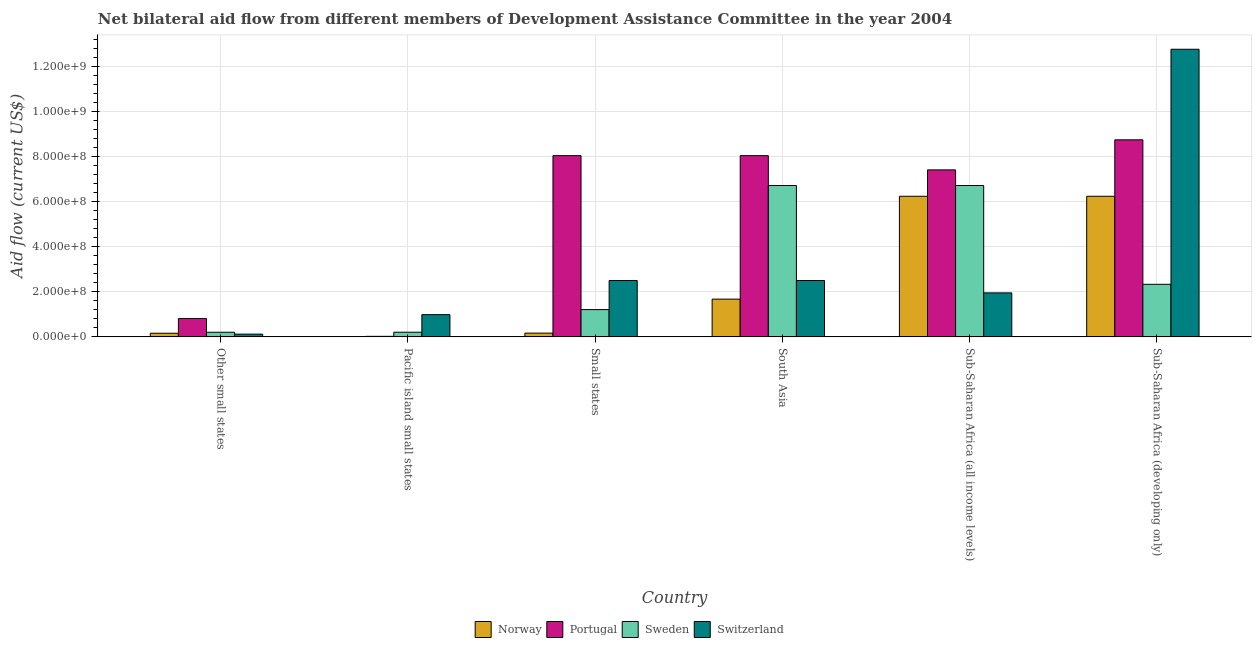Are the number of bars per tick equal to the number of legend labels?
Ensure brevity in your answer.  Yes. Are the number of bars on each tick of the X-axis equal?
Ensure brevity in your answer.  Yes. How many bars are there on the 6th tick from the left?
Provide a short and direct response. 4. How many bars are there on the 5th tick from the right?
Make the answer very short. 4. What is the label of the 5th group of bars from the left?
Your answer should be very brief. Sub-Saharan Africa (all income levels). What is the amount of aid given by portugal in Small states?
Make the answer very short. 8.04e+08. Across all countries, what is the maximum amount of aid given by portugal?
Make the answer very short. 8.74e+08. Across all countries, what is the minimum amount of aid given by switzerland?
Give a very brief answer. 1.22e+07. In which country was the amount of aid given by switzerland maximum?
Provide a short and direct response. Sub-Saharan Africa (developing only). In which country was the amount of aid given by norway minimum?
Provide a short and direct response. Pacific island small states. What is the total amount of aid given by switzerland in the graph?
Offer a very short reply. 2.08e+09. What is the difference between the amount of aid given by switzerland in Small states and that in Sub-Saharan Africa (developing only)?
Make the answer very short. -1.03e+09. What is the difference between the amount of aid given by portugal in Small states and the amount of aid given by switzerland in Other small states?
Give a very brief answer. 7.92e+08. What is the average amount of aid given by sweden per country?
Ensure brevity in your answer.  2.90e+08. What is the difference between the amount of aid given by switzerland and amount of aid given by sweden in Sub-Saharan Africa (all income levels)?
Make the answer very short. -4.76e+08. What is the ratio of the amount of aid given by norway in Pacific island small states to that in Sub-Saharan Africa (all income levels)?
Provide a succinct answer. 4.8117020594084814e-5. What is the difference between the highest and the second highest amount of aid given by switzerland?
Offer a very short reply. 1.03e+09. What is the difference between the highest and the lowest amount of aid given by switzerland?
Ensure brevity in your answer.  1.26e+09. What does the 3rd bar from the left in Other small states represents?
Ensure brevity in your answer.  Sweden. Is it the case that in every country, the sum of the amount of aid given by norway and amount of aid given by portugal is greater than the amount of aid given by sweden?
Offer a very short reply. No. Are all the bars in the graph horizontal?
Your response must be concise. No. Are the values on the major ticks of Y-axis written in scientific E-notation?
Offer a very short reply. Yes. Does the graph contain any zero values?
Your answer should be very brief. No. Does the graph contain grids?
Your answer should be very brief. Yes. How many legend labels are there?
Provide a succinct answer. 4. How are the legend labels stacked?
Give a very brief answer. Horizontal. What is the title of the graph?
Offer a terse response. Net bilateral aid flow from different members of Development Assistance Committee in the year 2004. What is the label or title of the X-axis?
Your answer should be very brief. Country. What is the Aid flow (current US$) of Norway in Other small states?
Your answer should be compact. 1.62e+07. What is the Aid flow (current US$) in Portugal in Other small states?
Your answer should be very brief. 8.14e+07. What is the Aid flow (current US$) of Sweden in Other small states?
Give a very brief answer. 2.04e+07. What is the Aid flow (current US$) in Switzerland in Other small states?
Provide a short and direct response. 1.22e+07. What is the Aid flow (current US$) in Portugal in Pacific island small states?
Give a very brief answer. 2.38e+06. What is the Aid flow (current US$) of Sweden in Pacific island small states?
Provide a short and direct response. 2.07e+07. What is the Aid flow (current US$) in Switzerland in Pacific island small states?
Provide a short and direct response. 9.84e+07. What is the Aid flow (current US$) of Norway in Small states?
Give a very brief answer. 1.66e+07. What is the Aid flow (current US$) of Portugal in Small states?
Your response must be concise. 8.04e+08. What is the Aid flow (current US$) in Sweden in Small states?
Keep it short and to the point. 1.21e+08. What is the Aid flow (current US$) of Switzerland in Small states?
Give a very brief answer. 2.50e+08. What is the Aid flow (current US$) in Norway in South Asia?
Ensure brevity in your answer.  1.67e+08. What is the Aid flow (current US$) in Portugal in South Asia?
Make the answer very short. 8.04e+08. What is the Aid flow (current US$) of Sweden in South Asia?
Make the answer very short. 6.71e+08. What is the Aid flow (current US$) of Switzerland in South Asia?
Your answer should be very brief. 2.50e+08. What is the Aid flow (current US$) in Norway in Sub-Saharan Africa (all income levels)?
Your answer should be very brief. 6.23e+08. What is the Aid flow (current US$) in Portugal in Sub-Saharan Africa (all income levels)?
Provide a succinct answer. 7.41e+08. What is the Aid flow (current US$) of Sweden in Sub-Saharan Africa (all income levels)?
Your answer should be compact. 6.71e+08. What is the Aid flow (current US$) of Switzerland in Sub-Saharan Africa (all income levels)?
Provide a succinct answer. 1.95e+08. What is the Aid flow (current US$) of Norway in Sub-Saharan Africa (developing only)?
Provide a succinct answer. 6.23e+08. What is the Aid flow (current US$) of Portugal in Sub-Saharan Africa (developing only)?
Your response must be concise. 8.74e+08. What is the Aid flow (current US$) of Sweden in Sub-Saharan Africa (developing only)?
Make the answer very short. 2.33e+08. What is the Aid flow (current US$) of Switzerland in Sub-Saharan Africa (developing only)?
Offer a terse response. 1.28e+09. Across all countries, what is the maximum Aid flow (current US$) in Norway?
Ensure brevity in your answer.  6.23e+08. Across all countries, what is the maximum Aid flow (current US$) in Portugal?
Your answer should be compact. 8.74e+08. Across all countries, what is the maximum Aid flow (current US$) of Sweden?
Your answer should be very brief. 6.71e+08. Across all countries, what is the maximum Aid flow (current US$) of Switzerland?
Provide a short and direct response. 1.28e+09. Across all countries, what is the minimum Aid flow (current US$) of Norway?
Ensure brevity in your answer.  3.00e+04. Across all countries, what is the minimum Aid flow (current US$) of Portugal?
Give a very brief answer. 2.38e+06. Across all countries, what is the minimum Aid flow (current US$) in Sweden?
Offer a very short reply. 2.04e+07. Across all countries, what is the minimum Aid flow (current US$) in Switzerland?
Offer a very short reply. 1.22e+07. What is the total Aid flow (current US$) in Norway in the graph?
Your answer should be compact. 1.45e+09. What is the total Aid flow (current US$) in Portugal in the graph?
Give a very brief answer. 3.31e+09. What is the total Aid flow (current US$) in Sweden in the graph?
Keep it short and to the point. 1.74e+09. What is the total Aid flow (current US$) in Switzerland in the graph?
Your answer should be very brief. 2.08e+09. What is the difference between the Aid flow (current US$) of Norway in Other small states and that in Pacific island small states?
Offer a terse response. 1.62e+07. What is the difference between the Aid flow (current US$) in Portugal in Other small states and that in Pacific island small states?
Ensure brevity in your answer.  7.90e+07. What is the difference between the Aid flow (current US$) in Sweden in Other small states and that in Pacific island small states?
Offer a very short reply. -2.40e+05. What is the difference between the Aid flow (current US$) in Switzerland in Other small states and that in Pacific island small states?
Provide a succinct answer. -8.63e+07. What is the difference between the Aid flow (current US$) of Norway in Other small states and that in Small states?
Your answer should be compact. -4.60e+05. What is the difference between the Aid flow (current US$) of Portugal in Other small states and that in Small states?
Your response must be concise. -7.22e+08. What is the difference between the Aid flow (current US$) of Sweden in Other small states and that in Small states?
Provide a succinct answer. -1.01e+08. What is the difference between the Aid flow (current US$) of Switzerland in Other small states and that in Small states?
Ensure brevity in your answer.  -2.38e+08. What is the difference between the Aid flow (current US$) in Norway in Other small states and that in South Asia?
Keep it short and to the point. -1.51e+08. What is the difference between the Aid flow (current US$) of Portugal in Other small states and that in South Asia?
Keep it short and to the point. -7.22e+08. What is the difference between the Aid flow (current US$) in Sweden in Other small states and that in South Asia?
Your response must be concise. -6.51e+08. What is the difference between the Aid flow (current US$) of Switzerland in Other small states and that in South Asia?
Give a very brief answer. -2.38e+08. What is the difference between the Aid flow (current US$) of Norway in Other small states and that in Sub-Saharan Africa (all income levels)?
Give a very brief answer. -6.07e+08. What is the difference between the Aid flow (current US$) in Portugal in Other small states and that in Sub-Saharan Africa (all income levels)?
Offer a terse response. -6.59e+08. What is the difference between the Aid flow (current US$) in Sweden in Other small states and that in Sub-Saharan Africa (all income levels)?
Provide a succinct answer. -6.51e+08. What is the difference between the Aid flow (current US$) in Switzerland in Other small states and that in Sub-Saharan Africa (all income levels)?
Offer a terse response. -1.83e+08. What is the difference between the Aid flow (current US$) in Norway in Other small states and that in Sub-Saharan Africa (developing only)?
Offer a terse response. -6.07e+08. What is the difference between the Aid flow (current US$) of Portugal in Other small states and that in Sub-Saharan Africa (developing only)?
Make the answer very short. -7.92e+08. What is the difference between the Aid flow (current US$) of Sweden in Other small states and that in Sub-Saharan Africa (developing only)?
Your answer should be very brief. -2.13e+08. What is the difference between the Aid flow (current US$) of Switzerland in Other small states and that in Sub-Saharan Africa (developing only)?
Provide a succinct answer. -1.26e+09. What is the difference between the Aid flow (current US$) of Norway in Pacific island small states and that in Small states?
Keep it short and to the point. -1.66e+07. What is the difference between the Aid flow (current US$) in Portugal in Pacific island small states and that in Small states?
Provide a short and direct response. -8.01e+08. What is the difference between the Aid flow (current US$) in Sweden in Pacific island small states and that in Small states?
Make the answer very short. -1.00e+08. What is the difference between the Aid flow (current US$) of Switzerland in Pacific island small states and that in Small states?
Your answer should be compact. -1.52e+08. What is the difference between the Aid flow (current US$) in Norway in Pacific island small states and that in South Asia?
Offer a very short reply. -1.67e+08. What is the difference between the Aid flow (current US$) of Portugal in Pacific island small states and that in South Asia?
Keep it short and to the point. -8.01e+08. What is the difference between the Aid flow (current US$) in Sweden in Pacific island small states and that in South Asia?
Provide a succinct answer. -6.50e+08. What is the difference between the Aid flow (current US$) in Switzerland in Pacific island small states and that in South Asia?
Offer a very short reply. -1.52e+08. What is the difference between the Aid flow (current US$) in Norway in Pacific island small states and that in Sub-Saharan Africa (all income levels)?
Give a very brief answer. -6.23e+08. What is the difference between the Aid flow (current US$) in Portugal in Pacific island small states and that in Sub-Saharan Africa (all income levels)?
Make the answer very short. -7.38e+08. What is the difference between the Aid flow (current US$) in Sweden in Pacific island small states and that in Sub-Saharan Africa (all income levels)?
Provide a short and direct response. -6.50e+08. What is the difference between the Aid flow (current US$) of Switzerland in Pacific island small states and that in Sub-Saharan Africa (all income levels)?
Keep it short and to the point. -9.66e+07. What is the difference between the Aid flow (current US$) of Norway in Pacific island small states and that in Sub-Saharan Africa (developing only)?
Your answer should be compact. -6.23e+08. What is the difference between the Aid flow (current US$) of Portugal in Pacific island small states and that in Sub-Saharan Africa (developing only)?
Your response must be concise. -8.71e+08. What is the difference between the Aid flow (current US$) in Sweden in Pacific island small states and that in Sub-Saharan Africa (developing only)?
Your response must be concise. -2.12e+08. What is the difference between the Aid flow (current US$) of Switzerland in Pacific island small states and that in Sub-Saharan Africa (developing only)?
Give a very brief answer. -1.18e+09. What is the difference between the Aid flow (current US$) in Norway in Small states and that in South Asia?
Keep it short and to the point. -1.51e+08. What is the difference between the Aid flow (current US$) of Portugal in Small states and that in South Asia?
Your answer should be compact. 5.00e+04. What is the difference between the Aid flow (current US$) of Sweden in Small states and that in South Asia?
Offer a terse response. -5.50e+08. What is the difference between the Aid flow (current US$) in Norway in Small states and that in Sub-Saharan Africa (all income levels)?
Provide a succinct answer. -6.07e+08. What is the difference between the Aid flow (current US$) of Portugal in Small states and that in Sub-Saharan Africa (all income levels)?
Offer a very short reply. 6.32e+07. What is the difference between the Aid flow (current US$) in Sweden in Small states and that in Sub-Saharan Africa (all income levels)?
Your answer should be very brief. -5.50e+08. What is the difference between the Aid flow (current US$) in Switzerland in Small states and that in Sub-Saharan Africa (all income levels)?
Offer a terse response. 5.50e+07. What is the difference between the Aid flow (current US$) in Norway in Small states and that in Sub-Saharan Africa (developing only)?
Give a very brief answer. -6.07e+08. What is the difference between the Aid flow (current US$) of Portugal in Small states and that in Sub-Saharan Africa (developing only)?
Your response must be concise. -7.02e+07. What is the difference between the Aid flow (current US$) in Sweden in Small states and that in Sub-Saharan Africa (developing only)?
Ensure brevity in your answer.  -1.12e+08. What is the difference between the Aid flow (current US$) in Switzerland in Small states and that in Sub-Saharan Africa (developing only)?
Make the answer very short. -1.03e+09. What is the difference between the Aid flow (current US$) of Norway in South Asia and that in Sub-Saharan Africa (all income levels)?
Provide a short and direct response. -4.56e+08. What is the difference between the Aid flow (current US$) in Portugal in South Asia and that in Sub-Saharan Africa (all income levels)?
Your answer should be compact. 6.31e+07. What is the difference between the Aid flow (current US$) in Sweden in South Asia and that in Sub-Saharan Africa (all income levels)?
Offer a very short reply. 0. What is the difference between the Aid flow (current US$) of Switzerland in South Asia and that in Sub-Saharan Africa (all income levels)?
Ensure brevity in your answer.  5.49e+07. What is the difference between the Aid flow (current US$) in Norway in South Asia and that in Sub-Saharan Africa (developing only)?
Your response must be concise. -4.56e+08. What is the difference between the Aid flow (current US$) of Portugal in South Asia and that in Sub-Saharan Africa (developing only)?
Provide a short and direct response. -7.02e+07. What is the difference between the Aid flow (current US$) of Sweden in South Asia and that in Sub-Saharan Africa (developing only)?
Your answer should be very brief. 4.38e+08. What is the difference between the Aid flow (current US$) of Switzerland in South Asia and that in Sub-Saharan Africa (developing only)?
Offer a very short reply. -1.03e+09. What is the difference between the Aid flow (current US$) of Portugal in Sub-Saharan Africa (all income levels) and that in Sub-Saharan Africa (developing only)?
Make the answer very short. -1.33e+08. What is the difference between the Aid flow (current US$) in Sweden in Sub-Saharan Africa (all income levels) and that in Sub-Saharan Africa (developing only)?
Offer a very short reply. 4.38e+08. What is the difference between the Aid flow (current US$) of Switzerland in Sub-Saharan Africa (all income levels) and that in Sub-Saharan Africa (developing only)?
Your response must be concise. -1.08e+09. What is the difference between the Aid flow (current US$) in Norway in Other small states and the Aid flow (current US$) in Portugal in Pacific island small states?
Provide a short and direct response. 1.38e+07. What is the difference between the Aid flow (current US$) in Norway in Other small states and the Aid flow (current US$) in Sweden in Pacific island small states?
Offer a terse response. -4.50e+06. What is the difference between the Aid flow (current US$) in Norway in Other small states and the Aid flow (current US$) in Switzerland in Pacific island small states?
Ensure brevity in your answer.  -8.23e+07. What is the difference between the Aid flow (current US$) in Portugal in Other small states and the Aid flow (current US$) in Sweden in Pacific island small states?
Give a very brief answer. 6.07e+07. What is the difference between the Aid flow (current US$) in Portugal in Other small states and the Aid flow (current US$) in Switzerland in Pacific island small states?
Your answer should be compact. -1.71e+07. What is the difference between the Aid flow (current US$) in Sweden in Other small states and the Aid flow (current US$) in Switzerland in Pacific island small states?
Provide a short and direct response. -7.80e+07. What is the difference between the Aid flow (current US$) in Norway in Other small states and the Aid flow (current US$) in Portugal in Small states?
Your response must be concise. -7.87e+08. What is the difference between the Aid flow (current US$) in Norway in Other small states and the Aid flow (current US$) in Sweden in Small states?
Your answer should be very brief. -1.05e+08. What is the difference between the Aid flow (current US$) in Norway in Other small states and the Aid flow (current US$) in Switzerland in Small states?
Ensure brevity in your answer.  -2.34e+08. What is the difference between the Aid flow (current US$) of Portugal in Other small states and the Aid flow (current US$) of Sweden in Small states?
Your response must be concise. -3.96e+07. What is the difference between the Aid flow (current US$) in Portugal in Other small states and the Aid flow (current US$) in Switzerland in Small states?
Provide a short and direct response. -1.69e+08. What is the difference between the Aid flow (current US$) in Sweden in Other small states and the Aid flow (current US$) in Switzerland in Small states?
Make the answer very short. -2.30e+08. What is the difference between the Aid flow (current US$) in Norway in Other small states and the Aid flow (current US$) in Portugal in South Asia?
Your response must be concise. -7.87e+08. What is the difference between the Aid flow (current US$) in Norway in Other small states and the Aid flow (current US$) in Sweden in South Asia?
Your response must be concise. -6.55e+08. What is the difference between the Aid flow (current US$) in Norway in Other small states and the Aid flow (current US$) in Switzerland in South Asia?
Provide a short and direct response. -2.34e+08. What is the difference between the Aid flow (current US$) of Portugal in Other small states and the Aid flow (current US$) of Sweden in South Asia?
Your response must be concise. -5.90e+08. What is the difference between the Aid flow (current US$) in Portugal in Other small states and the Aid flow (current US$) in Switzerland in South Asia?
Provide a short and direct response. -1.69e+08. What is the difference between the Aid flow (current US$) of Sweden in Other small states and the Aid flow (current US$) of Switzerland in South Asia?
Provide a short and direct response. -2.30e+08. What is the difference between the Aid flow (current US$) of Norway in Other small states and the Aid flow (current US$) of Portugal in Sub-Saharan Africa (all income levels)?
Provide a short and direct response. -7.24e+08. What is the difference between the Aid flow (current US$) of Norway in Other small states and the Aid flow (current US$) of Sweden in Sub-Saharan Africa (all income levels)?
Make the answer very short. -6.55e+08. What is the difference between the Aid flow (current US$) of Norway in Other small states and the Aid flow (current US$) of Switzerland in Sub-Saharan Africa (all income levels)?
Your answer should be compact. -1.79e+08. What is the difference between the Aid flow (current US$) of Portugal in Other small states and the Aid flow (current US$) of Sweden in Sub-Saharan Africa (all income levels)?
Make the answer very short. -5.90e+08. What is the difference between the Aid flow (current US$) of Portugal in Other small states and the Aid flow (current US$) of Switzerland in Sub-Saharan Africa (all income levels)?
Your answer should be very brief. -1.14e+08. What is the difference between the Aid flow (current US$) of Sweden in Other small states and the Aid flow (current US$) of Switzerland in Sub-Saharan Africa (all income levels)?
Provide a short and direct response. -1.75e+08. What is the difference between the Aid flow (current US$) of Norway in Other small states and the Aid flow (current US$) of Portugal in Sub-Saharan Africa (developing only)?
Offer a very short reply. -8.58e+08. What is the difference between the Aid flow (current US$) of Norway in Other small states and the Aid flow (current US$) of Sweden in Sub-Saharan Africa (developing only)?
Keep it short and to the point. -2.17e+08. What is the difference between the Aid flow (current US$) of Norway in Other small states and the Aid flow (current US$) of Switzerland in Sub-Saharan Africa (developing only)?
Your response must be concise. -1.26e+09. What is the difference between the Aid flow (current US$) in Portugal in Other small states and the Aid flow (current US$) in Sweden in Sub-Saharan Africa (developing only)?
Offer a terse response. -1.52e+08. What is the difference between the Aid flow (current US$) in Portugal in Other small states and the Aid flow (current US$) in Switzerland in Sub-Saharan Africa (developing only)?
Offer a terse response. -1.19e+09. What is the difference between the Aid flow (current US$) of Sweden in Other small states and the Aid flow (current US$) of Switzerland in Sub-Saharan Africa (developing only)?
Your response must be concise. -1.25e+09. What is the difference between the Aid flow (current US$) in Norway in Pacific island small states and the Aid flow (current US$) in Portugal in Small states?
Keep it short and to the point. -8.04e+08. What is the difference between the Aid flow (current US$) in Norway in Pacific island small states and the Aid flow (current US$) in Sweden in Small states?
Offer a terse response. -1.21e+08. What is the difference between the Aid flow (current US$) in Norway in Pacific island small states and the Aid flow (current US$) in Switzerland in Small states?
Offer a terse response. -2.50e+08. What is the difference between the Aid flow (current US$) in Portugal in Pacific island small states and the Aid flow (current US$) in Sweden in Small states?
Keep it short and to the point. -1.19e+08. What is the difference between the Aid flow (current US$) in Portugal in Pacific island small states and the Aid flow (current US$) in Switzerland in Small states?
Make the answer very short. -2.48e+08. What is the difference between the Aid flow (current US$) in Sweden in Pacific island small states and the Aid flow (current US$) in Switzerland in Small states?
Your answer should be very brief. -2.29e+08. What is the difference between the Aid flow (current US$) of Norway in Pacific island small states and the Aid flow (current US$) of Portugal in South Asia?
Provide a succinct answer. -8.04e+08. What is the difference between the Aid flow (current US$) in Norway in Pacific island small states and the Aid flow (current US$) in Sweden in South Asia?
Your response must be concise. -6.71e+08. What is the difference between the Aid flow (current US$) of Norway in Pacific island small states and the Aid flow (current US$) of Switzerland in South Asia?
Give a very brief answer. -2.50e+08. What is the difference between the Aid flow (current US$) in Portugal in Pacific island small states and the Aid flow (current US$) in Sweden in South Asia?
Ensure brevity in your answer.  -6.69e+08. What is the difference between the Aid flow (current US$) of Portugal in Pacific island small states and the Aid flow (current US$) of Switzerland in South Asia?
Give a very brief answer. -2.48e+08. What is the difference between the Aid flow (current US$) in Sweden in Pacific island small states and the Aid flow (current US$) in Switzerland in South Asia?
Make the answer very short. -2.29e+08. What is the difference between the Aid flow (current US$) in Norway in Pacific island small states and the Aid flow (current US$) in Portugal in Sub-Saharan Africa (all income levels)?
Give a very brief answer. -7.40e+08. What is the difference between the Aid flow (current US$) of Norway in Pacific island small states and the Aid flow (current US$) of Sweden in Sub-Saharan Africa (all income levels)?
Offer a terse response. -6.71e+08. What is the difference between the Aid flow (current US$) in Norway in Pacific island small states and the Aid flow (current US$) in Switzerland in Sub-Saharan Africa (all income levels)?
Give a very brief answer. -1.95e+08. What is the difference between the Aid flow (current US$) of Portugal in Pacific island small states and the Aid flow (current US$) of Sweden in Sub-Saharan Africa (all income levels)?
Offer a very short reply. -6.69e+08. What is the difference between the Aid flow (current US$) in Portugal in Pacific island small states and the Aid flow (current US$) in Switzerland in Sub-Saharan Africa (all income levels)?
Provide a short and direct response. -1.93e+08. What is the difference between the Aid flow (current US$) in Sweden in Pacific island small states and the Aid flow (current US$) in Switzerland in Sub-Saharan Africa (all income levels)?
Your answer should be compact. -1.74e+08. What is the difference between the Aid flow (current US$) of Norway in Pacific island small states and the Aid flow (current US$) of Portugal in Sub-Saharan Africa (developing only)?
Keep it short and to the point. -8.74e+08. What is the difference between the Aid flow (current US$) in Norway in Pacific island small states and the Aid flow (current US$) in Sweden in Sub-Saharan Africa (developing only)?
Offer a terse response. -2.33e+08. What is the difference between the Aid flow (current US$) in Norway in Pacific island small states and the Aid flow (current US$) in Switzerland in Sub-Saharan Africa (developing only)?
Your answer should be compact. -1.28e+09. What is the difference between the Aid flow (current US$) of Portugal in Pacific island small states and the Aid flow (current US$) of Sweden in Sub-Saharan Africa (developing only)?
Your answer should be compact. -2.31e+08. What is the difference between the Aid flow (current US$) of Portugal in Pacific island small states and the Aid flow (current US$) of Switzerland in Sub-Saharan Africa (developing only)?
Your answer should be very brief. -1.27e+09. What is the difference between the Aid flow (current US$) in Sweden in Pacific island small states and the Aid flow (current US$) in Switzerland in Sub-Saharan Africa (developing only)?
Provide a succinct answer. -1.25e+09. What is the difference between the Aid flow (current US$) in Norway in Small states and the Aid flow (current US$) in Portugal in South Asia?
Offer a very short reply. -7.87e+08. What is the difference between the Aid flow (current US$) of Norway in Small states and the Aid flow (current US$) of Sweden in South Asia?
Ensure brevity in your answer.  -6.54e+08. What is the difference between the Aid flow (current US$) in Norway in Small states and the Aid flow (current US$) in Switzerland in South Asia?
Provide a succinct answer. -2.33e+08. What is the difference between the Aid flow (current US$) in Portugal in Small states and the Aid flow (current US$) in Sweden in South Asia?
Offer a terse response. 1.33e+08. What is the difference between the Aid flow (current US$) of Portugal in Small states and the Aid flow (current US$) of Switzerland in South Asia?
Give a very brief answer. 5.54e+08. What is the difference between the Aid flow (current US$) in Sweden in Small states and the Aid flow (current US$) in Switzerland in South Asia?
Provide a succinct answer. -1.29e+08. What is the difference between the Aid flow (current US$) of Norway in Small states and the Aid flow (current US$) of Portugal in Sub-Saharan Africa (all income levels)?
Your answer should be compact. -7.24e+08. What is the difference between the Aid flow (current US$) in Norway in Small states and the Aid flow (current US$) in Sweden in Sub-Saharan Africa (all income levels)?
Provide a succinct answer. -6.54e+08. What is the difference between the Aid flow (current US$) of Norway in Small states and the Aid flow (current US$) of Switzerland in Sub-Saharan Africa (all income levels)?
Provide a short and direct response. -1.78e+08. What is the difference between the Aid flow (current US$) in Portugal in Small states and the Aid flow (current US$) in Sweden in Sub-Saharan Africa (all income levels)?
Offer a terse response. 1.33e+08. What is the difference between the Aid flow (current US$) in Portugal in Small states and the Aid flow (current US$) in Switzerland in Sub-Saharan Africa (all income levels)?
Give a very brief answer. 6.09e+08. What is the difference between the Aid flow (current US$) of Sweden in Small states and the Aid flow (current US$) of Switzerland in Sub-Saharan Africa (all income levels)?
Your answer should be compact. -7.41e+07. What is the difference between the Aid flow (current US$) in Norway in Small states and the Aid flow (current US$) in Portugal in Sub-Saharan Africa (developing only)?
Keep it short and to the point. -8.57e+08. What is the difference between the Aid flow (current US$) of Norway in Small states and the Aid flow (current US$) of Sweden in Sub-Saharan Africa (developing only)?
Give a very brief answer. -2.16e+08. What is the difference between the Aid flow (current US$) in Norway in Small states and the Aid flow (current US$) in Switzerland in Sub-Saharan Africa (developing only)?
Keep it short and to the point. -1.26e+09. What is the difference between the Aid flow (current US$) in Portugal in Small states and the Aid flow (current US$) in Sweden in Sub-Saharan Africa (developing only)?
Your answer should be compact. 5.71e+08. What is the difference between the Aid flow (current US$) of Portugal in Small states and the Aid flow (current US$) of Switzerland in Sub-Saharan Africa (developing only)?
Make the answer very short. -4.72e+08. What is the difference between the Aid flow (current US$) in Sweden in Small states and the Aid flow (current US$) in Switzerland in Sub-Saharan Africa (developing only)?
Provide a succinct answer. -1.15e+09. What is the difference between the Aid flow (current US$) of Norway in South Asia and the Aid flow (current US$) of Portugal in Sub-Saharan Africa (all income levels)?
Give a very brief answer. -5.73e+08. What is the difference between the Aid flow (current US$) of Norway in South Asia and the Aid flow (current US$) of Sweden in Sub-Saharan Africa (all income levels)?
Offer a terse response. -5.04e+08. What is the difference between the Aid flow (current US$) in Norway in South Asia and the Aid flow (current US$) in Switzerland in Sub-Saharan Africa (all income levels)?
Provide a succinct answer. -2.77e+07. What is the difference between the Aid flow (current US$) of Portugal in South Asia and the Aid flow (current US$) of Sweden in Sub-Saharan Africa (all income levels)?
Provide a succinct answer. 1.32e+08. What is the difference between the Aid flow (current US$) of Portugal in South Asia and the Aid flow (current US$) of Switzerland in Sub-Saharan Africa (all income levels)?
Offer a terse response. 6.09e+08. What is the difference between the Aid flow (current US$) of Sweden in South Asia and the Aid flow (current US$) of Switzerland in Sub-Saharan Africa (all income levels)?
Keep it short and to the point. 4.76e+08. What is the difference between the Aid flow (current US$) of Norway in South Asia and the Aid flow (current US$) of Portugal in Sub-Saharan Africa (developing only)?
Keep it short and to the point. -7.06e+08. What is the difference between the Aid flow (current US$) of Norway in South Asia and the Aid flow (current US$) of Sweden in Sub-Saharan Africa (developing only)?
Ensure brevity in your answer.  -6.57e+07. What is the difference between the Aid flow (current US$) of Norway in South Asia and the Aid flow (current US$) of Switzerland in Sub-Saharan Africa (developing only)?
Provide a succinct answer. -1.11e+09. What is the difference between the Aid flow (current US$) of Portugal in South Asia and the Aid flow (current US$) of Sweden in Sub-Saharan Africa (developing only)?
Make the answer very short. 5.71e+08. What is the difference between the Aid flow (current US$) in Portugal in South Asia and the Aid flow (current US$) in Switzerland in Sub-Saharan Africa (developing only)?
Make the answer very short. -4.72e+08. What is the difference between the Aid flow (current US$) in Sweden in South Asia and the Aid flow (current US$) in Switzerland in Sub-Saharan Africa (developing only)?
Offer a very short reply. -6.04e+08. What is the difference between the Aid flow (current US$) of Norway in Sub-Saharan Africa (all income levels) and the Aid flow (current US$) of Portugal in Sub-Saharan Africa (developing only)?
Ensure brevity in your answer.  -2.50e+08. What is the difference between the Aid flow (current US$) of Norway in Sub-Saharan Africa (all income levels) and the Aid flow (current US$) of Sweden in Sub-Saharan Africa (developing only)?
Your answer should be very brief. 3.90e+08. What is the difference between the Aid flow (current US$) in Norway in Sub-Saharan Africa (all income levels) and the Aid flow (current US$) in Switzerland in Sub-Saharan Africa (developing only)?
Offer a terse response. -6.52e+08. What is the difference between the Aid flow (current US$) in Portugal in Sub-Saharan Africa (all income levels) and the Aid flow (current US$) in Sweden in Sub-Saharan Africa (developing only)?
Ensure brevity in your answer.  5.07e+08. What is the difference between the Aid flow (current US$) in Portugal in Sub-Saharan Africa (all income levels) and the Aid flow (current US$) in Switzerland in Sub-Saharan Africa (developing only)?
Your response must be concise. -5.35e+08. What is the difference between the Aid flow (current US$) in Sweden in Sub-Saharan Africa (all income levels) and the Aid flow (current US$) in Switzerland in Sub-Saharan Africa (developing only)?
Give a very brief answer. -6.04e+08. What is the average Aid flow (current US$) in Norway per country?
Provide a succinct answer. 2.41e+08. What is the average Aid flow (current US$) in Portugal per country?
Provide a short and direct response. 5.51e+08. What is the average Aid flow (current US$) in Sweden per country?
Give a very brief answer. 2.90e+08. What is the average Aid flow (current US$) of Switzerland per country?
Give a very brief answer. 3.47e+08. What is the difference between the Aid flow (current US$) in Norway and Aid flow (current US$) in Portugal in Other small states?
Keep it short and to the point. -6.52e+07. What is the difference between the Aid flow (current US$) in Norway and Aid flow (current US$) in Sweden in Other small states?
Ensure brevity in your answer.  -4.26e+06. What is the difference between the Aid flow (current US$) of Norway and Aid flow (current US$) of Switzerland in Other small states?
Ensure brevity in your answer.  4.02e+06. What is the difference between the Aid flow (current US$) of Portugal and Aid flow (current US$) of Sweden in Other small states?
Ensure brevity in your answer.  6.09e+07. What is the difference between the Aid flow (current US$) in Portugal and Aid flow (current US$) in Switzerland in Other small states?
Offer a terse response. 6.92e+07. What is the difference between the Aid flow (current US$) of Sweden and Aid flow (current US$) of Switzerland in Other small states?
Your response must be concise. 8.28e+06. What is the difference between the Aid flow (current US$) in Norway and Aid flow (current US$) in Portugal in Pacific island small states?
Offer a very short reply. -2.35e+06. What is the difference between the Aid flow (current US$) of Norway and Aid flow (current US$) of Sweden in Pacific island small states?
Your answer should be compact. -2.07e+07. What is the difference between the Aid flow (current US$) of Norway and Aid flow (current US$) of Switzerland in Pacific island small states?
Keep it short and to the point. -9.84e+07. What is the difference between the Aid flow (current US$) of Portugal and Aid flow (current US$) of Sweden in Pacific island small states?
Your response must be concise. -1.83e+07. What is the difference between the Aid flow (current US$) of Portugal and Aid flow (current US$) of Switzerland in Pacific island small states?
Offer a very short reply. -9.61e+07. What is the difference between the Aid flow (current US$) of Sweden and Aid flow (current US$) of Switzerland in Pacific island small states?
Make the answer very short. -7.78e+07. What is the difference between the Aid flow (current US$) in Norway and Aid flow (current US$) in Portugal in Small states?
Offer a very short reply. -7.87e+08. What is the difference between the Aid flow (current US$) in Norway and Aid flow (current US$) in Sweden in Small states?
Offer a terse response. -1.04e+08. What is the difference between the Aid flow (current US$) of Norway and Aid flow (current US$) of Switzerland in Small states?
Your response must be concise. -2.33e+08. What is the difference between the Aid flow (current US$) in Portugal and Aid flow (current US$) in Sweden in Small states?
Your answer should be very brief. 6.83e+08. What is the difference between the Aid flow (current US$) of Portugal and Aid flow (current US$) of Switzerland in Small states?
Ensure brevity in your answer.  5.54e+08. What is the difference between the Aid flow (current US$) of Sweden and Aid flow (current US$) of Switzerland in Small states?
Your response must be concise. -1.29e+08. What is the difference between the Aid flow (current US$) in Norway and Aid flow (current US$) in Portugal in South Asia?
Provide a succinct answer. -6.36e+08. What is the difference between the Aid flow (current US$) in Norway and Aid flow (current US$) in Sweden in South Asia?
Make the answer very short. -5.04e+08. What is the difference between the Aid flow (current US$) of Norway and Aid flow (current US$) of Switzerland in South Asia?
Offer a very short reply. -8.26e+07. What is the difference between the Aid flow (current US$) of Portugal and Aid flow (current US$) of Sweden in South Asia?
Keep it short and to the point. 1.32e+08. What is the difference between the Aid flow (current US$) of Portugal and Aid flow (current US$) of Switzerland in South Asia?
Keep it short and to the point. 5.54e+08. What is the difference between the Aid flow (current US$) in Sweden and Aid flow (current US$) in Switzerland in South Asia?
Your answer should be very brief. 4.21e+08. What is the difference between the Aid flow (current US$) in Norway and Aid flow (current US$) in Portugal in Sub-Saharan Africa (all income levels)?
Provide a succinct answer. -1.17e+08. What is the difference between the Aid flow (current US$) of Norway and Aid flow (current US$) of Sweden in Sub-Saharan Africa (all income levels)?
Your answer should be compact. -4.77e+07. What is the difference between the Aid flow (current US$) in Norway and Aid flow (current US$) in Switzerland in Sub-Saharan Africa (all income levels)?
Keep it short and to the point. 4.28e+08. What is the difference between the Aid flow (current US$) in Portugal and Aid flow (current US$) in Sweden in Sub-Saharan Africa (all income levels)?
Make the answer very short. 6.94e+07. What is the difference between the Aid flow (current US$) of Portugal and Aid flow (current US$) of Switzerland in Sub-Saharan Africa (all income levels)?
Ensure brevity in your answer.  5.45e+08. What is the difference between the Aid flow (current US$) in Sweden and Aid flow (current US$) in Switzerland in Sub-Saharan Africa (all income levels)?
Keep it short and to the point. 4.76e+08. What is the difference between the Aid flow (current US$) of Norway and Aid flow (current US$) of Portugal in Sub-Saharan Africa (developing only)?
Ensure brevity in your answer.  -2.50e+08. What is the difference between the Aid flow (current US$) of Norway and Aid flow (current US$) of Sweden in Sub-Saharan Africa (developing only)?
Offer a terse response. 3.90e+08. What is the difference between the Aid flow (current US$) in Norway and Aid flow (current US$) in Switzerland in Sub-Saharan Africa (developing only)?
Keep it short and to the point. -6.52e+08. What is the difference between the Aid flow (current US$) of Portugal and Aid flow (current US$) of Sweden in Sub-Saharan Africa (developing only)?
Ensure brevity in your answer.  6.41e+08. What is the difference between the Aid flow (current US$) in Portugal and Aid flow (current US$) in Switzerland in Sub-Saharan Africa (developing only)?
Provide a succinct answer. -4.02e+08. What is the difference between the Aid flow (current US$) in Sweden and Aid flow (current US$) in Switzerland in Sub-Saharan Africa (developing only)?
Offer a terse response. -1.04e+09. What is the ratio of the Aid flow (current US$) of Norway in Other small states to that in Pacific island small states?
Provide a succinct answer. 539.67. What is the ratio of the Aid flow (current US$) of Portugal in Other small states to that in Pacific island small states?
Offer a very short reply. 34.19. What is the ratio of the Aid flow (current US$) of Sweden in Other small states to that in Pacific island small states?
Provide a short and direct response. 0.99. What is the ratio of the Aid flow (current US$) in Switzerland in Other small states to that in Pacific island small states?
Ensure brevity in your answer.  0.12. What is the ratio of the Aid flow (current US$) of Norway in Other small states to that in Small states?
Your answer should be compact. 0.97. What is the ratio of the Aid flow (current US$) in Portugal in Other small states to that in Small states?
Your answer should be compact. 0.1. What is the ratio of the Aid flow (current US$) of Sweden in Other small states to that in Small states?
Your answer should be compact. 0.17. What is the ratio of the Aid flow (current US$) of Switzerland in Other small states to that in Small states?
Make the answer very short. 0.05. What is the ratio of the Aid flow (current US$) of Norway in Other small states to that in South Asia?
Give a very brief answer. 0.1. What is the ratio of the Aid flow (current US$) of Portugal in Other small states to that in South Asia?
Provide a short and direct response. 0.1. What is the ratio of the Aid flow (current US$) in Sweden in Other small states to that in South Asia?
Your response must be concise. 0.03. What is the ratio of the Aid flow (current US$) in Switzerland in Other small states to that in South Asia?
Your response must be concise. 0.05. What is the ratio of the Aid flow (current US$) of Norway in Other small states to that in Sub-Saharan Africa (all income levels)?
Ensure brevity in your answer.  0.03. What is the ratio of the Aid flow (current US$) in Portugal in Other small states to that in Sub-Saharan Africa (all income levels)?
Give a very brief answer. 0.11. What is the ratio of the Aid flow (current US$) in Sweden in Other small states to that in Sub-Saharan Africa (all income levels)?
Your response must be concise. 0.03. What is the ratio of the Aid flow (current US$) in Switzerland in Other small states to that in Sub-Saharan Africa (all income levels)?
Give a very brief answer. 0.06. What is the ratio of the Aid flow (current US$) of Norway in Other small states to that in Sub-Saharan Africa (developing only)?
Offer a very short reply. 0.03. What is the ratio of the Aid flow (current US$) in Portugal in Other small states to that in Sub-Saharan Africa (developing only)?
Provide a short and direct response. 0.09. What is the ratio of the Aid flow (current US$) in Sweden in Other small states to that in Sub-Saharan Africa (developing only)?
Provide a short and direct response. 0.09. What is the ratio of the Aid flow (current US$) in Switzerland in Other small states to that in Sub-Saharan Africa (developing only)?
Your answer should be very brief. 0.01. What is the ratio of the Aid flow (current US$) in Norway in Pacific island small states to that in Small states?
Give a very brief answer. 0. What is the ratio of the Aid flow (current US$) in Portugal in Pacific island small states to that in Small states?
Offer a terse response. 0. What is the ratio of the Aid flow (current US$) of Sweden in Pacific island small states to that in Small states?
Provide a short and direct response. 0.17. What is the ratio of the Aid flow (current US$) in Switzerland in Pacific island small states to that in Small states?
Give a very brief answer. 0.39. What is the ratio of the Aid flow (current US$) of Portugal in Pacific island small states to that in South Asia?
Keep it short and to the point. 0. What is the ratio of the Aid flow (current US$) in Sweden in Pacific island small states to that in South Asia?
Provide a succinct answer. 0.03. What is the ratio of the Aid flow (current US$) in Switzerland in Pacific island small states to that in South Asia?
Your answer should be very brief. 0.39. What is the ratio of the Aid flow (current US$) of Norway in Pacific island small states to that in Sub-Saharan Africa (all income levels)?
Ensure brevity in your answer.  0. What is the ratio of the Aid flow (current US$) in Portugal in Pacific island small states to that in Sub-Saharan Africa (all income levels)?
Provide a succinct answer. 0. What is the ratio of the Aid flow (current US$) in Sweden in Pacific island small states to that in Sub-Saharan Africa (all income levels)?
Provide a short and direct response. 0.03. What is the ratio of the Aid flow (current US$) of Switzerland in Pacific island small states to that in Sub-Saharan Africa (all income levels)?
Offer a terse response. 0.5. What is the ratio of the Aid flow (current US$) in Portugal in Pacific island small states to that in Sub-Saharan Africa (developing only)?
Keep it short and to the point. 0. What is the ratio of the Aid flow (current US$) of Sweden in Pacific island small states to that in Sub-Saharan Africa (developing only)?
Your response must be concise. 0.09. What is the ratio of the Aid flow (current US$) in Switzerland in Pacific island small states to that in Sub-Saharan Africa (developing only)?
Make the answer very short. 0.08. What is the ratio of the Aid flow (current US$) of Norway in Small states to that in South Asia?
Make the answer very short. 0.1. What is the ratio of the Aid flow (current US$) of Sweden in Small states to that in South Asia?
Provide a short and direct response. 0.18. What is the ratio of the Aid flow (current US$) of Norway in Small states to that in Sub-Saharan Africa (all income levels)?
Ensure brevity in your answer.  0.03. What is the ratio of the Aid flow (current US$) in Portugal in Small states to that in Sub-Saharan Africa (all income levels)?
Your answer should be compact. 1.09. What is the ratio of the Aid flow (current US$) in Sweden in Small states to that in Sub-Saharan Africa (all income levels)?
Provide a short and direct response. 0.18. What is the ratio of the Aid flow (current US$) in Switzerland in Small states to that in Sub-Saharan Africa (all income levels)?
Give a very brief answer. 1.28. What is the ratio of the Aid flow (current US$) of Norway in Small states to that in Sub-Saharan Africa (developing only)?
Offer a very short reply. 0.03. What is the ratio of the Aid flow (current US$) of Portugal in Small states to that in Sub-Saharan Africa (developing only)?
Provide a succinct answer. 0.92. What is the ratio of the Aid flow (current US$) of Sweden in Small states to that in Sub-Saharan Africa (developing only)?
Provide a succinct answer. 0.52. What is the ratio of the Aid flow (current US$) in Switzerland in Small states to that in Sub-Saharan Africa (developing only)?
Provide a succinct answer. 0.2. What is the ratio of the Aid flow (current US$) in Norway in South Asia to that in Sub-Saharan Africa (all income levels)?
Provide a short and direct response. 0.27. What is the ratio of the Aid flow (current US$) of Portugal in South Asia to that in Sub-Saharan Africa (all income levels)?
Your answer should be very brief. 1.09. What is the ratio of the Aid flow (current US$) of Sweden in South Asia to that in Sub-Saharan Africa (all income levels)?
Offer a very short reply. 1. What is the ratio of the Aid flow (current US$) in Switzerland in South Asia to that in Sub-Saharan Africa (all income levels)?
Make the answer very short. 1.28. What is the ratio of the Aid flow (current US$) of Norway in South Asia to that in Sub-Saharan Africa (developing only)?
Provide a succinct answer. 0.27. What is the ratio of the Aid flow (current US$) of Portugal in South Asia to that in Sub-Saharan Africa (developing only)?
Offer a very short reply. 0.92. What is the ratio of the Aid flow (current US$) of Sweden in South Asia to that in Sub-Saharan Africa (developing only)?
Give a very brief answer. 2.88. What is the ratio of the Aid flow (current US$) in Switzerland in South Asia to that in Sub-Saharan Africa (developing only)?
Your answer should be compact. 0.2. What is the ratio of the Aid flow (current US$) of Portugal in Sub-Saharan Africa (all income levels) to that in Sub-Saharan Africa (developing only)?
Offer a very short reply. 0.85. What is the ratio of the Aid flow (current US$) of Sweden in Sub-Saharan Africa (all income levels) to that in Sub-Saharan Africa (developing only)?
Give a very brief answer. 2.88. What is the ratio of the Aid flow (current US$) in Switzerland in Sub-Saharan Africa (all income levels) to that in Sub-Saharan Africa (developing only)?
Offer a very short reply. 0.15. What is the difference between the highest and the second highest Aid flow (current US$) of Norway?
Offer a terse response. 0. What is the difference between the highest and the second highest Aid flow (current US$) in Portugal?
Ensure brevity in your answer.  7.02e+07. What is the difference between the highest and the second highest Aid flow (current US$) of Switzerland?
Provide a short and direct response. 1.03e+09. What is the difference between the highest and the lowest Aid flow (current US$) of Norway?
Keep it short and to the point. 6.23e+08. What is the difference between the highest and the lowest Aid flow (current US$) in Portugal?
Your answer should be very brief. 8.71e+08. What is the difference between the highest and the lowest Aid flow (current US$) of Sweden?
Your answer should be very brief. 6.51e+08. What is the difference between the highest and the lowest Aid flow (current US$) in Switzerland?
Your answer should be very brief. 1.26e+09. 